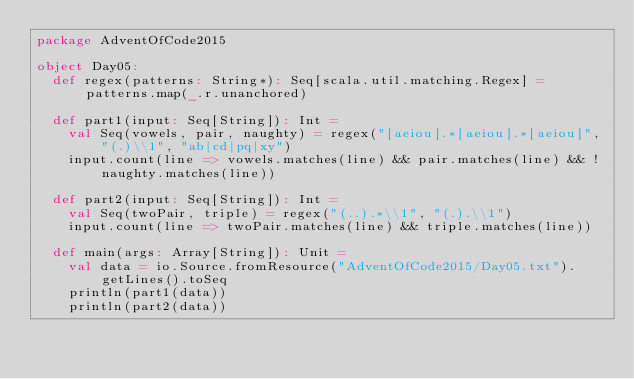Convert code to text. <code><loc_0><loc_0><loc_500><loc_500><_Scala_>package AdventOfCode2015

object Day05:
  def regex(patterns: String*): Seq[scala.util.matching.Regex] = patterns.map(_.r.unanchored)

  def part1(input: Seq[String]): Int =
    val Seq(vowels, pair, naughty) = regex("[aeiou].*[aeiou].*[aeiou]", "(.)\\1", "ab|cd|pq|xy")
    input.count(line => vowels.matches(line) && pair.matches(line) && !naughty.matches(line))

  def part2(input: Seq[String]): Int =
    val Seq(twoPair, triple) = regex("(..).*\\1", "(.).\\1")
    input.count(line => twoPair.matches(line) && triple.matches(line))

  def main(args: Array[String]): Unit =
    val data = io.Source.fromResource("AdventOfCode2015/Day05.txt").getLines().toSeq
    println(part1(data))
    println(part2(data))
</code> 